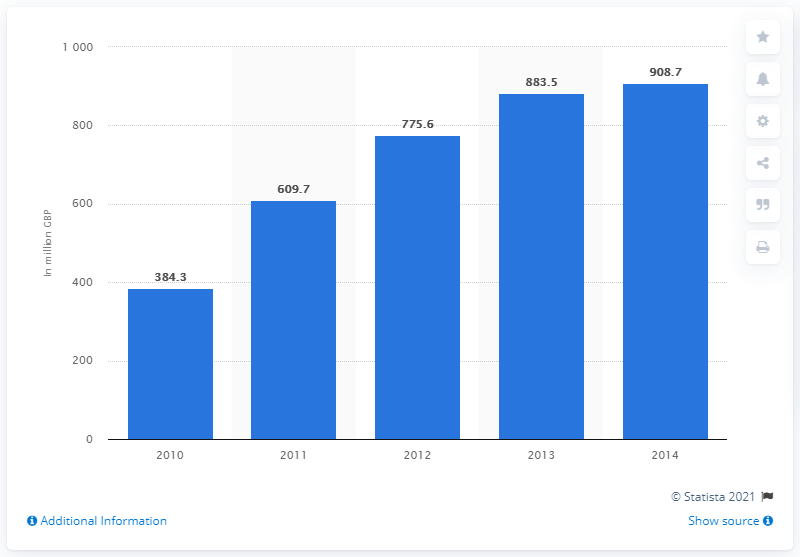Point out several critical features in this image. In the year 2014, the value of microtransaction revenues in the UK was approximately 908.7 million pounds. In the year 2010, the value of microtransaction revenues in the UK totaled 384.3 million pounds. 